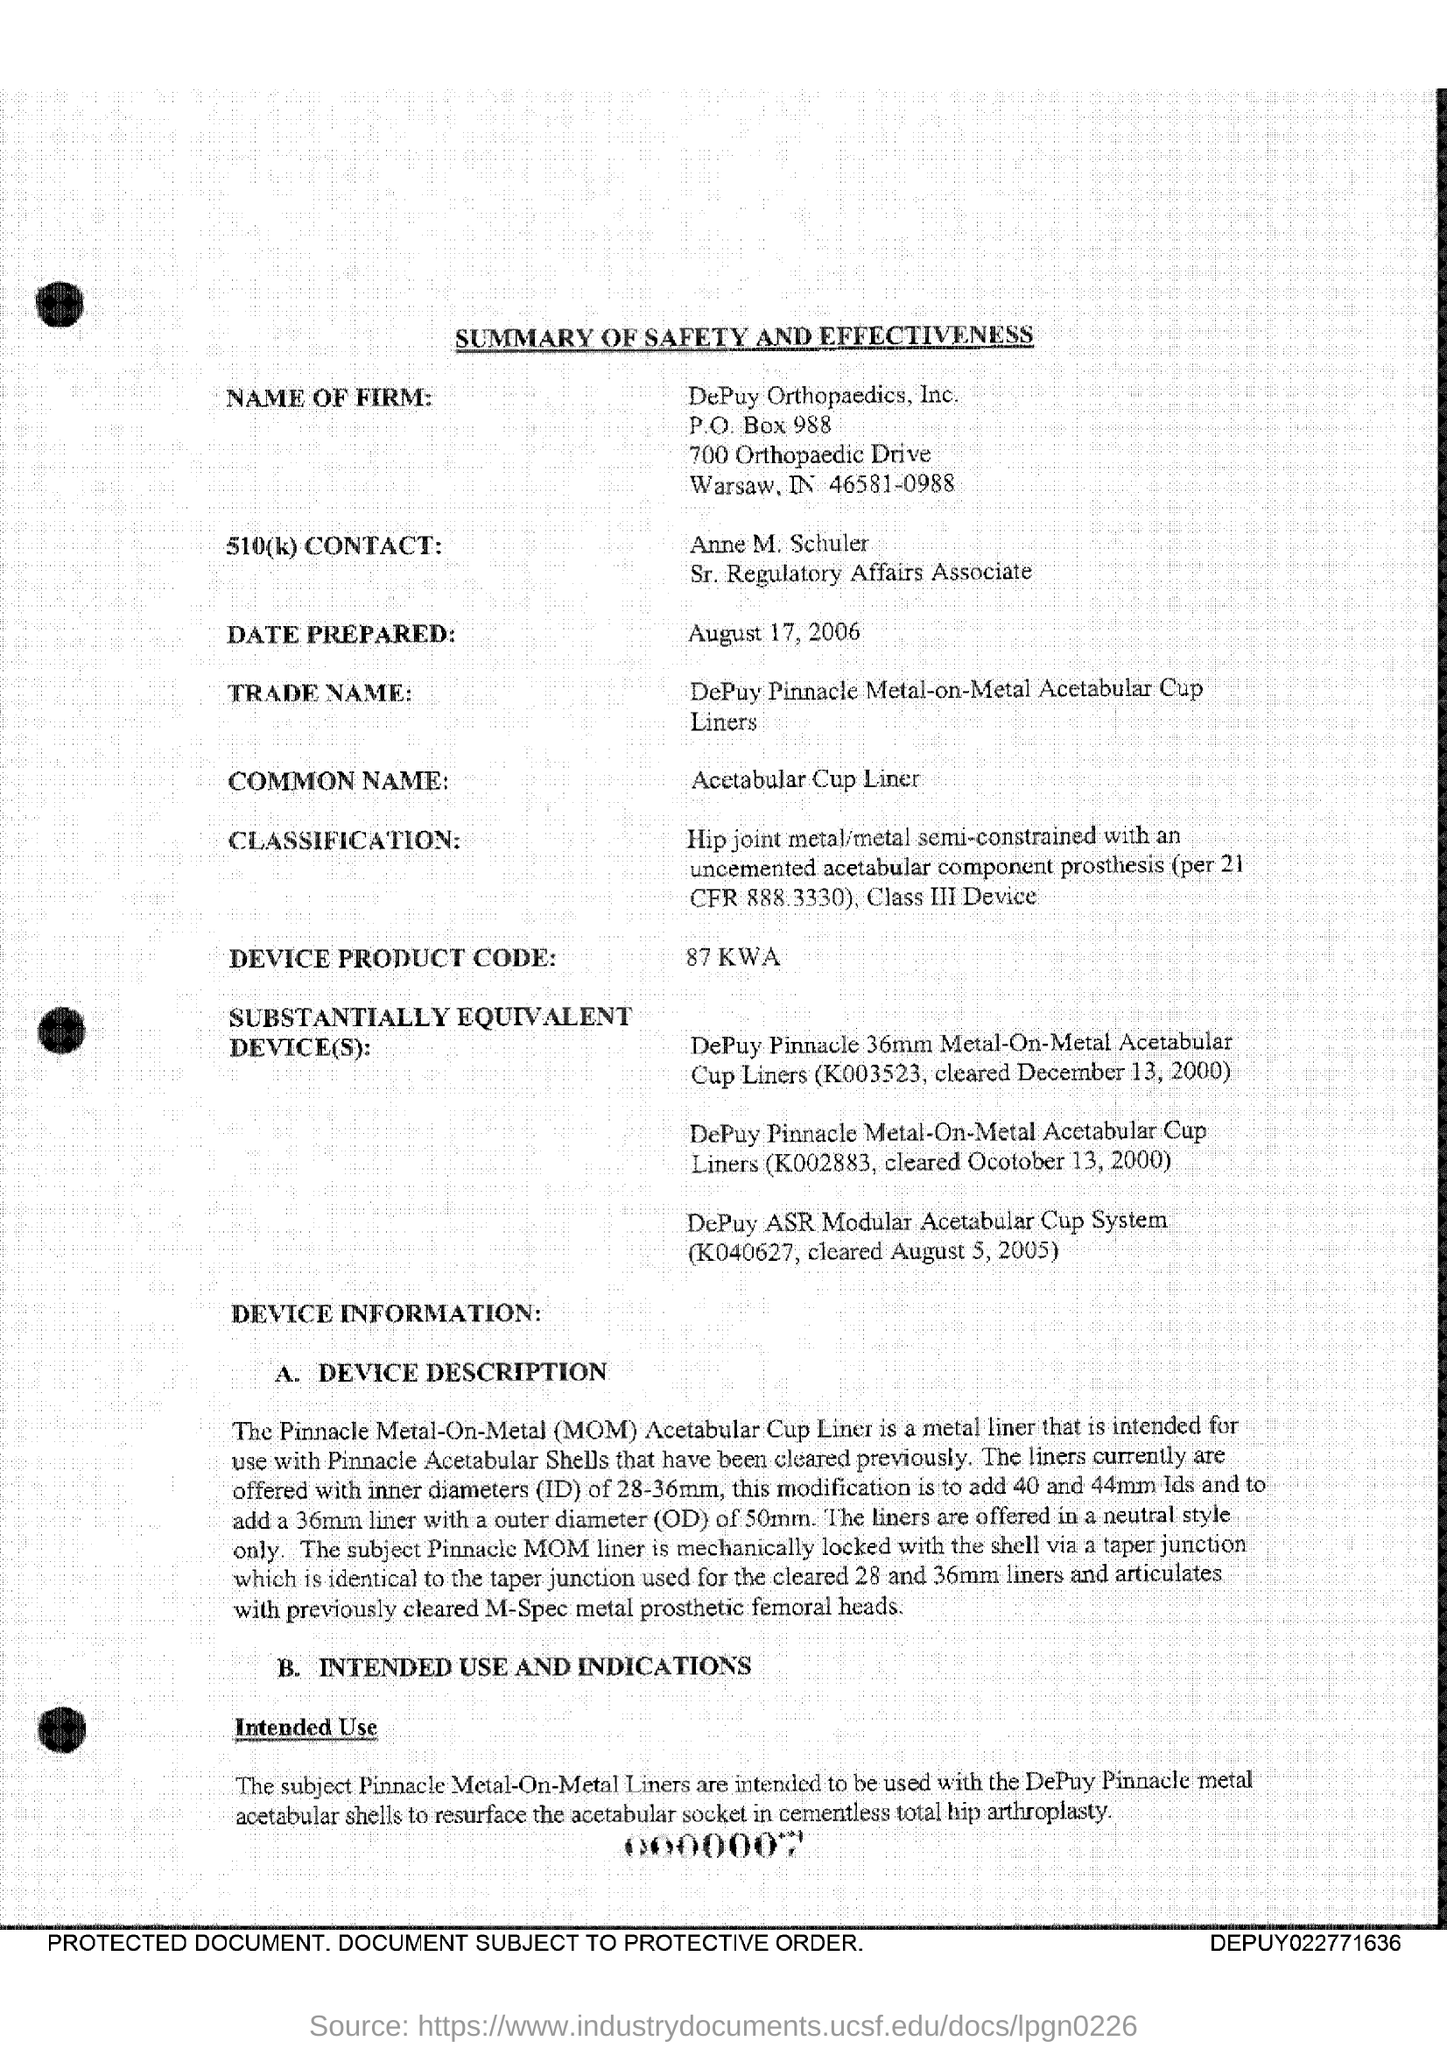Highlight a few significant elements in this photo. The PO Box number of DePuy Orthopaedics, Inc is 988... The common name for the device is the acetabular cup liner. The acronym MOM stands for Metal-on-Metal, representing the use of metal components in direct contact with each other in various engineering applications. Anne M. Schuler holds the position of Sr. regulatory affairs associate. The term 'ID' refers to inner diameters, and it is commonly used in the context of discussing the dimensions of various types of tubing or piping. 